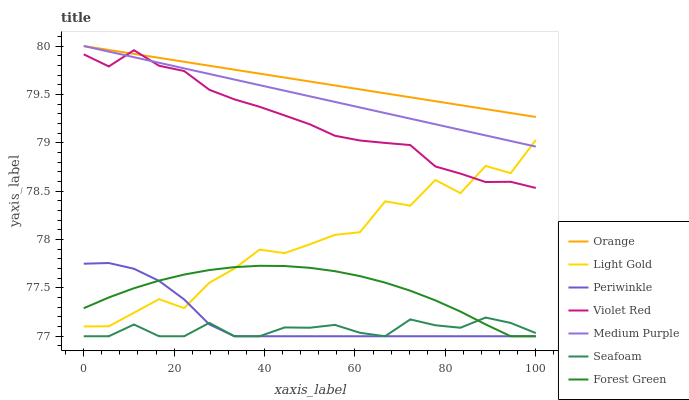Does Medium Purple have the minimum area under the curve?
Answer yes or no. No. Does Medium Purple have the maximum area under the curve?
Answer yes or no. No. Is Seafoam the smoothest?
Answer yes or no. No. Is Seafoam the roughest?
Answer yes or no. No. Does Medium Purple have the lowest value?
Answer yes or no. No. Does Seafoam have the highest value?
Answer yes or no. No. Is Forest Green less than Orange?
Answer yes or no. Yes. Is Light Gold greater than Seafoam?
Answer yes or no. Yes. Does Forest Green intersect Orange?
Answer yes or no. No. 